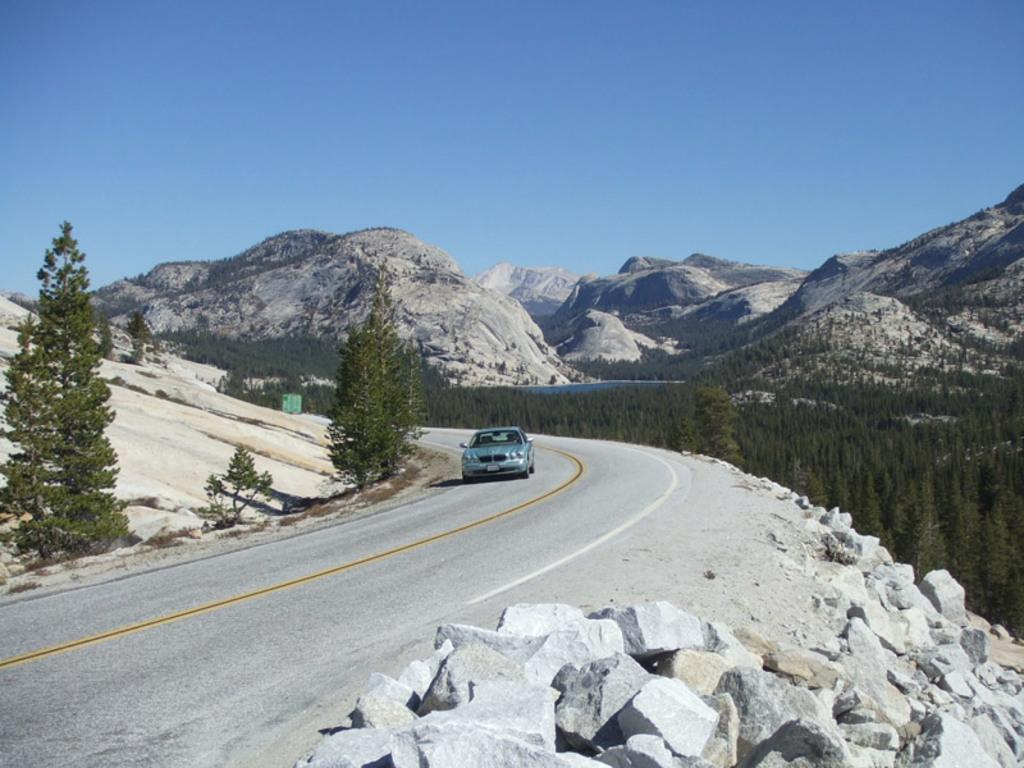What is the main subject of the image? There is a car in the image. Where is the car located? The car is on the road. What can be seen at the bottom of the image? There are rocks at the bottom of the image. What type of natural features are visible in the background of the image? There are trees, hills, and the sky visible in the background of the image. What type of tank is visible in the image? There is no tank present in the image; it features a car on the road. What is the car resting on in the image? The car is not resting on anything specific in the image; it is simply on the road. 